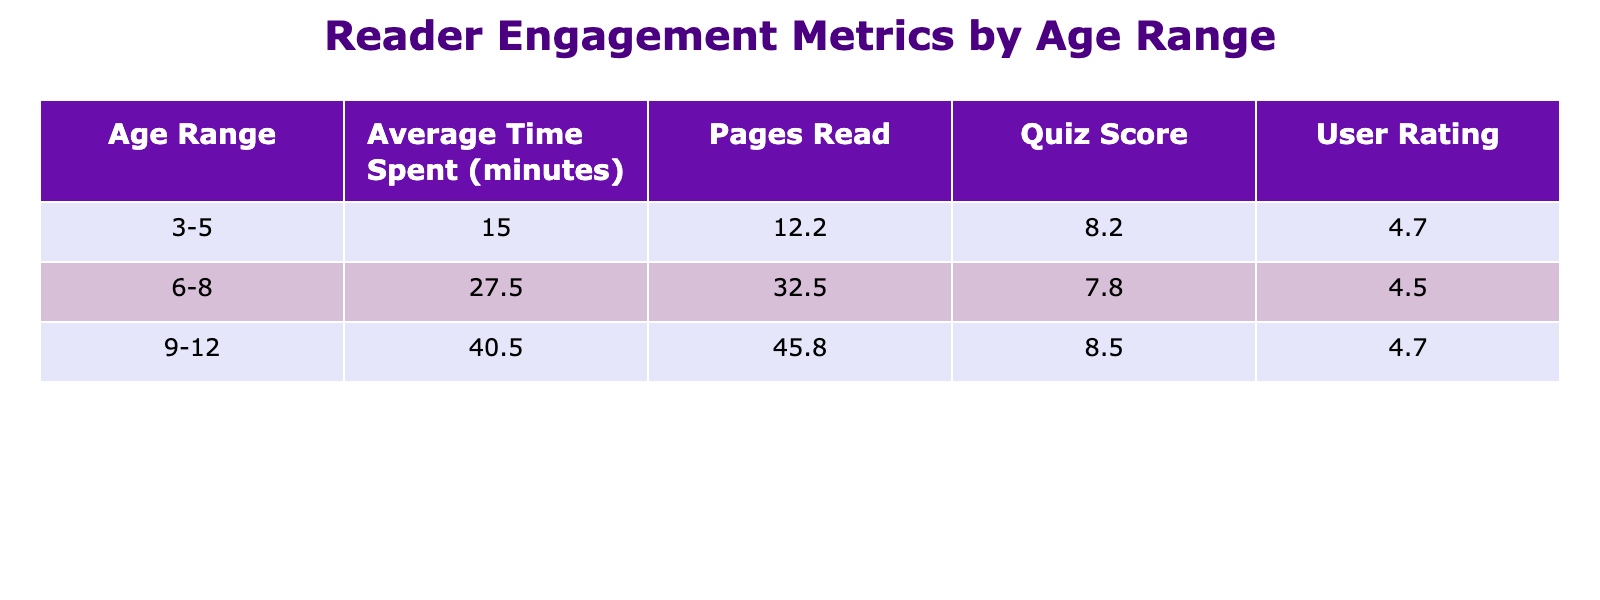What is the average user rating for the age range 3-5? To find the average user rating for the age range 3-5, we look at the user ratings of each e-book in that category: 4.7, 4.5, 4.8, 4.6, and 4.8. The sum of these ratings is 4.7 + 4.5 + 4.8 + 4.6 + 4.8 = 24.4, and since there are 5 e-books, the average is 24.4 / 5 = 4.88.
Answer: 4.9 How many pages on average do readers of ages 6-8 read? For the age range 6-8, the pages read are 30, 35, 32, 33, 34, and 31. The total pages read is 30 + 35 + 32 + 33 + 34 + 31 = 195. There are 6 entries, so the average is 195 / 6 = 32.5.
Answer: 32.5 Is the average quiz score for age range 9-12 above 8? The average quiz scores for the e-books in the age range 9-12 are 8, 9, 8, 9, and 9. Adding these scores gives 8 + 9 + 8 + 9 + 9 = 43, and dividing by 5 reads the average score as 43 / 5 = 8.6, which is above 8.
Answer: Yes Which age range spent the most time on average with their e-books? The average time spent for age ranges can be compared: for 3-5 it is (15 + 12 + 18 + 14 + 16) / 5 = 15, for 6-8 it is (25 + 30 + 28 + 27 + 29 + 26) / 6 = 27.5, and for 9-12 it is (45 + 40 + 35 + 42 + 38 + 43) / 6 = 40.5. The highest average is 40.5 for age range 9-12.
Answer: 9-12 What is the median user rating for e-books targeted at age range 6-8? To find the median user rating for age range 6-8, we first list the ratings: 4.6, 4.4, 4.7, 4.5, and 4.3. Arranging these gives us: 4.3, 4.4, 4.5, 4.6, 4.7. The median is the middle value, which is 4.5.
Answer: 4.5 